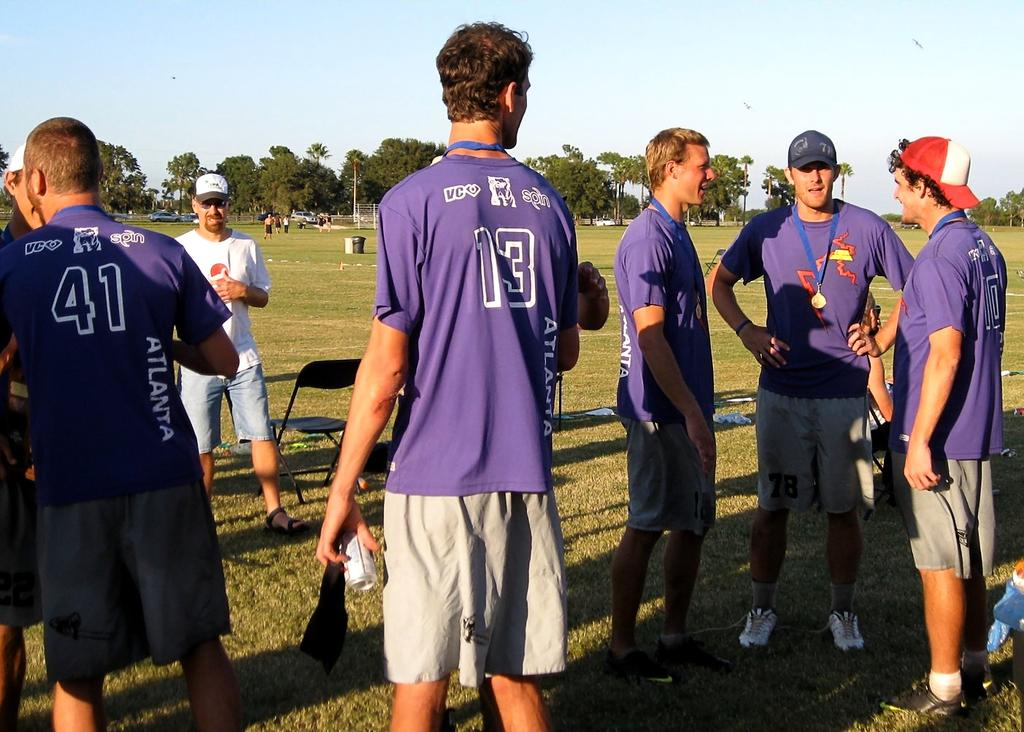<image>
Summarize the visual content of the image. Player number 13 is holding a drink can at his side. 